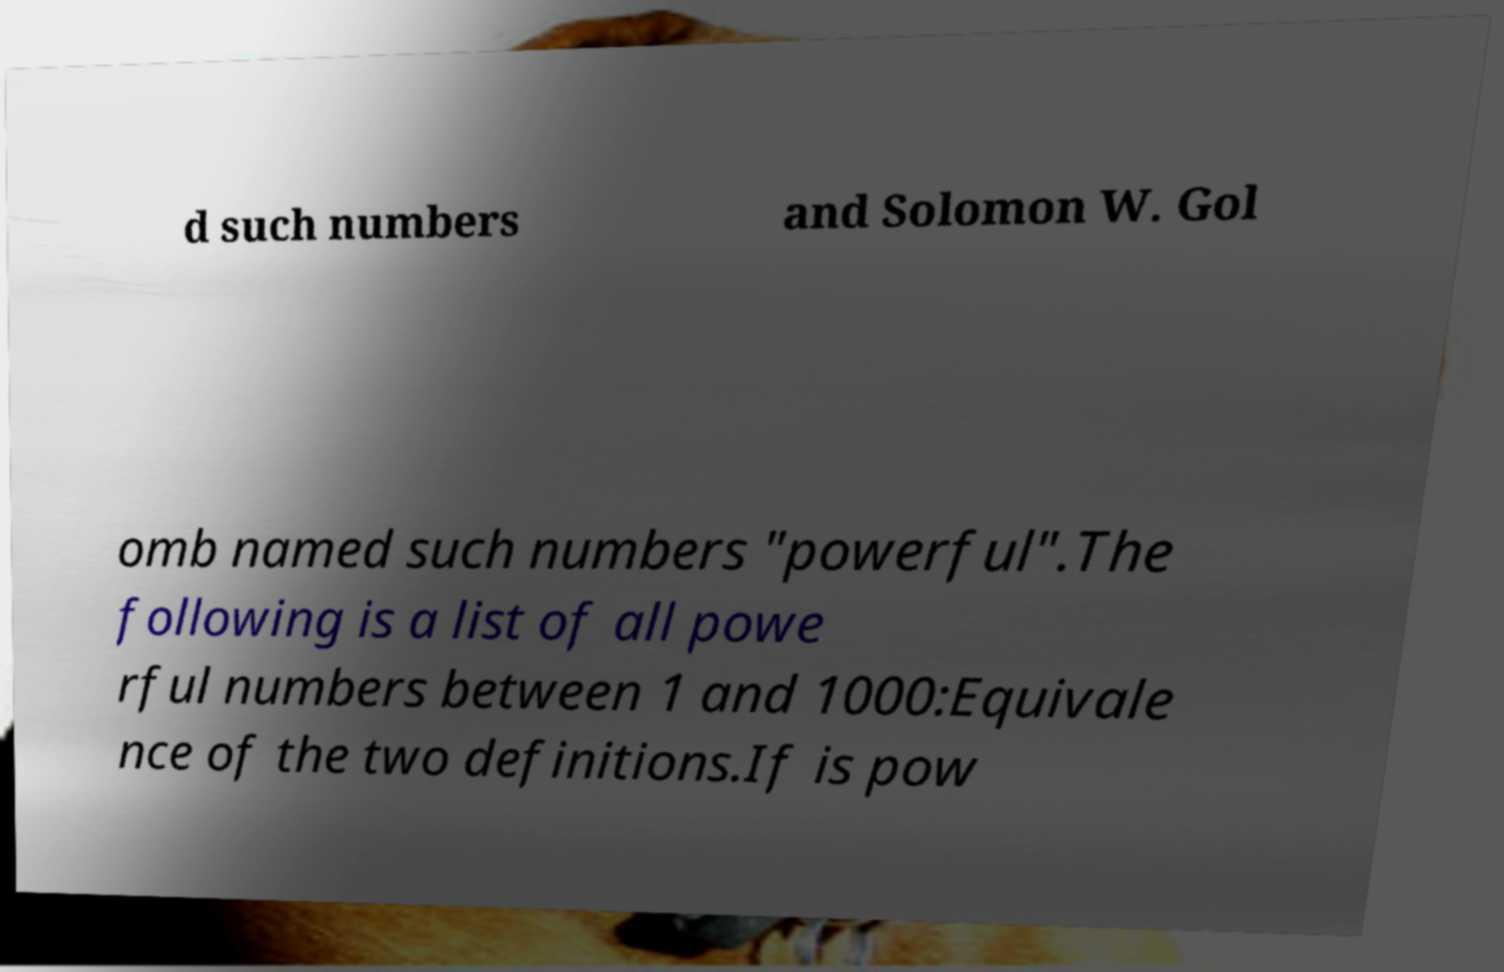I need the written content from this picture converted into text. Can you do that? d such numbers and Solomon W. Gol omb named such numbers "powerful".The following is a list of all powe rful numbers between 1 and 1000:Equivale nce of the two definitions.If is pow 